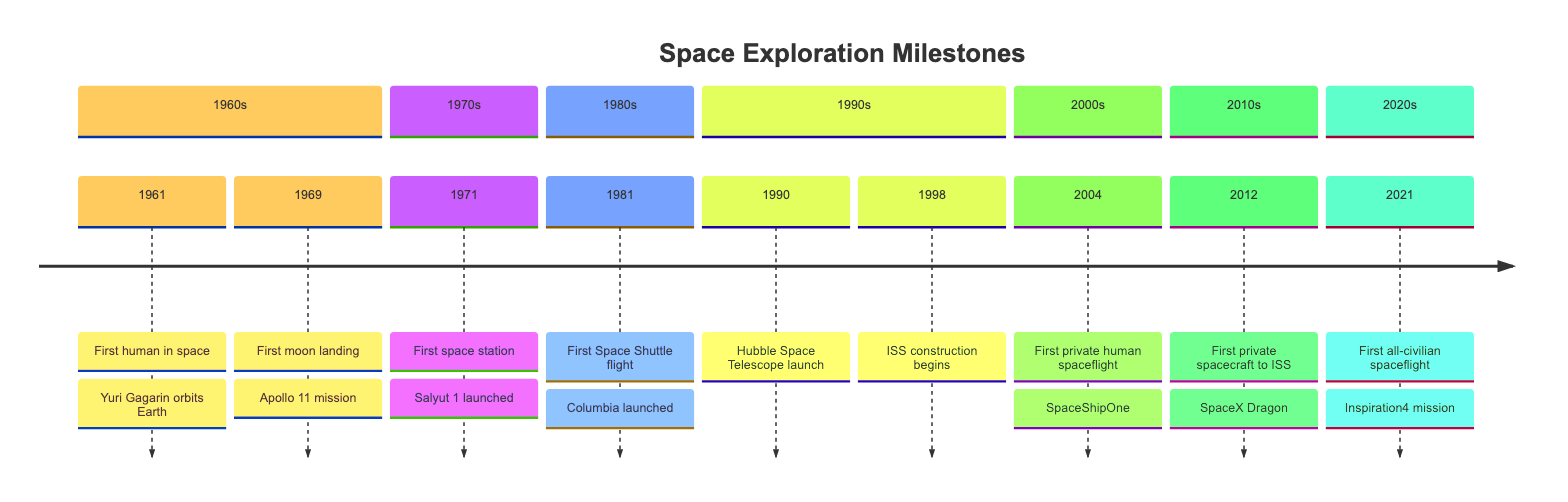What year was the first human in space? The first human in space was Yuri Gagarin in 1961. This is indicated in the diagram that lists milestones, where "1961" corresponds to "First human in space."
Answer: 1961 How many space exploration milestones are shown in the diagram? By counting the events listed in the timeline, we see there are a total of 10 milestones: from the first human in space in 1961 to the first all-civilian spaceflight in 2021.
Answer: 10 What event corresponds to the year 1981? The diagram shows that 1981 corresponds to the event "First Space Shuttle flight." This milestone is clearly labeled in the section for the 1980s, making it easy to identify.
Answer: First Space Shuttle flight What significant event happened in 1998? In 1998, the construction of the International Space Station (ISS) began, as noted in the timeline. This is a key milestone listed under the 1990s section of the diagram.
Answer: ISS construction begins Which event marks the beginning of a new era in private space travel? The event marking this new era is the first private human spaceflight, which occurred in 2004 with SpaceShipOne. This is noted in the 2000s section of the timeline, indicating its significance in private space exploration.
Answer: First private human spaceflight What does the diagram depict as the first commercial spacecraft to dock with the ISS? According to the timeline, SpaceX's Dragon spacecraft, which docked with the ISS in 2012, is depicted as the first commercial spacecraft to do so. This milestone is illustrated in the 2010s section of the diagram.
Answer: SpaceX Dragon How many events occurred in the 1990s? In the timeline, two events are listed for the 1990s: the launch of the Hubble Space Telescope in 1990 and the beginning of ISS construction in 1998. This is clearly shown, thus confirming the total number.
Answer: 2 Which two milestones are associated with the year 2021? The milestone associated with 2021 is "First all-civilian spaceflight," which is indicated in the timeline under the 2020s section. Since it is the only event noted for that year, it stands alone.
Answer: First all-civilian spaceflight 